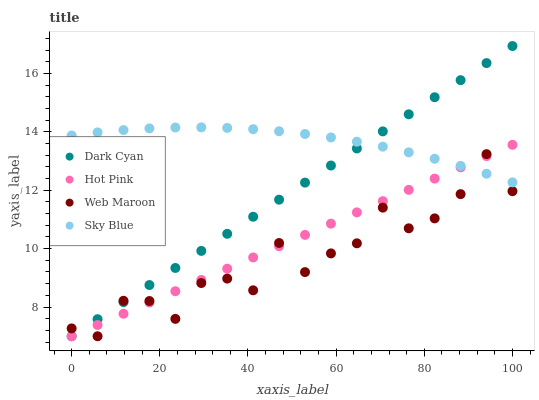Does Web Maroon have the minimum area under the curve?
Answer yes or no. Yes. Does Sky Blue have the maximum area under the curve?
Answer yes or no. Yes. Does Hot Pink have the minimum area under the curve?
Answer yes or no. No. Does Hot Pink have the maximum area under the curve?
Answer yes or no. No. Is Dark Cyan the smoothest?
Answer yes or no. Yes. Is Web Maroon the roughest?
Answer yes or no. Yes. Is Sky Blue the smoothest?
Answer yes or no. No. Is Sky Blue the roughest?
Answer yes or no. No. Does Dark Cyan have the lowest value?
Answer yes or no. Yes. Does Sky Blue have the lowest value?
Answer yes or no. No. Does Dark Cyan have the highest value?
Answer yes or no. Yes. Does Sky Blue have the highest value?
Answer yes or no. No. Does Hot Pink intersect Web Maroon?
Answer yes or no. Yes. Is Hot Pink less than Web Maroon?
Answer yes or no. No. Is Hot Pink greater than Web Maroon?
Answer yes or no. No. 